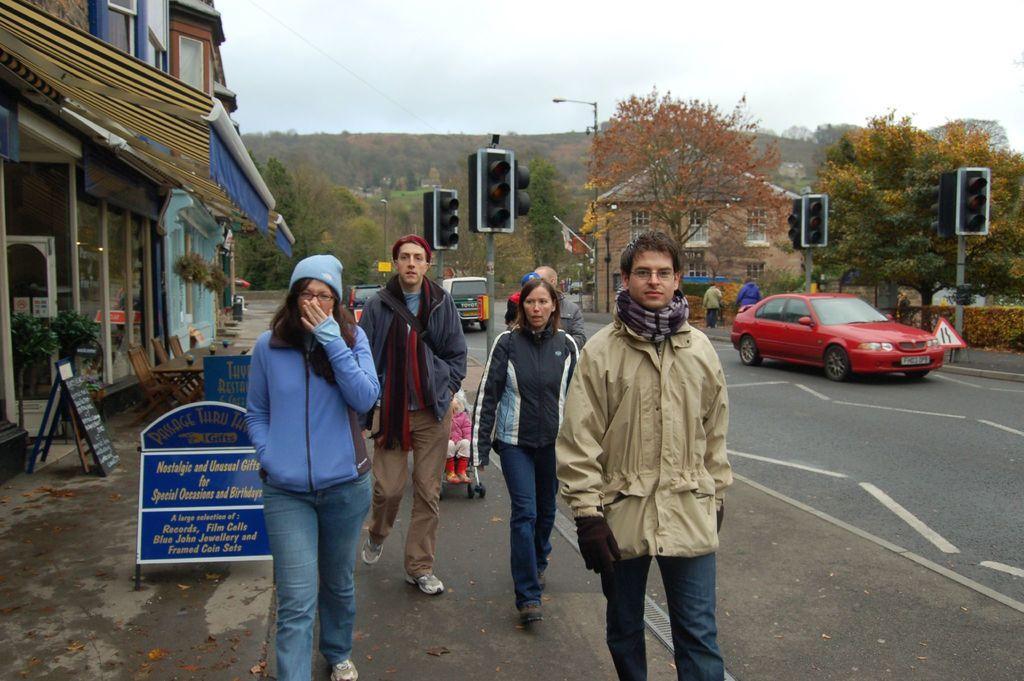Describe this image in one or two sentences. In this image I can see the vehicles on the road. To the side of the road I can see the signal poles, many trees and the group of people with different color dresses. I can see a child sitting in the stroller. To the left I can see many boards and the building. In the background I can see the house, many trees and the sky. 